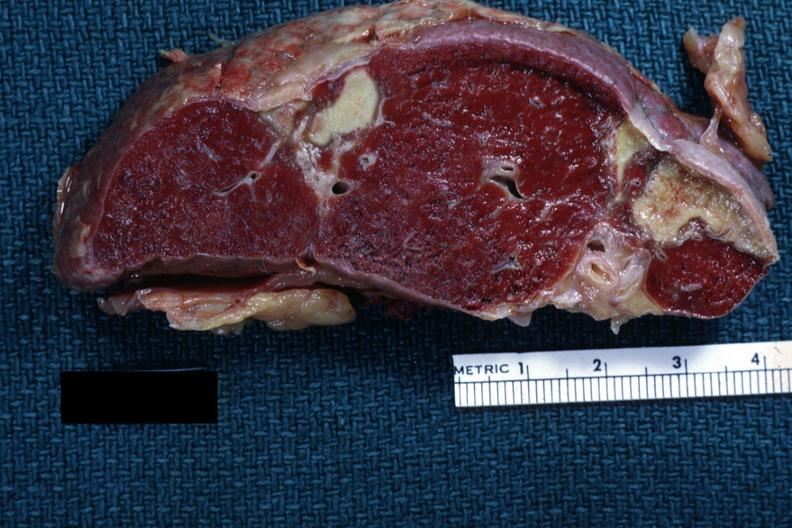does pituitary show excellentremote infarct with yellow centers?
Answer the question using a single word or phrase. No 